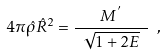Convert formula to latex. <formula><loc_0><loc_0><loc_500><loc_500>4 \pi \hat { \rho } \hat { R } ^ { 2 } = \frac { M ^ { ^ { \prime } } } { \ \sqrt { 1 + 2 E } \ } \ ,</formula> 